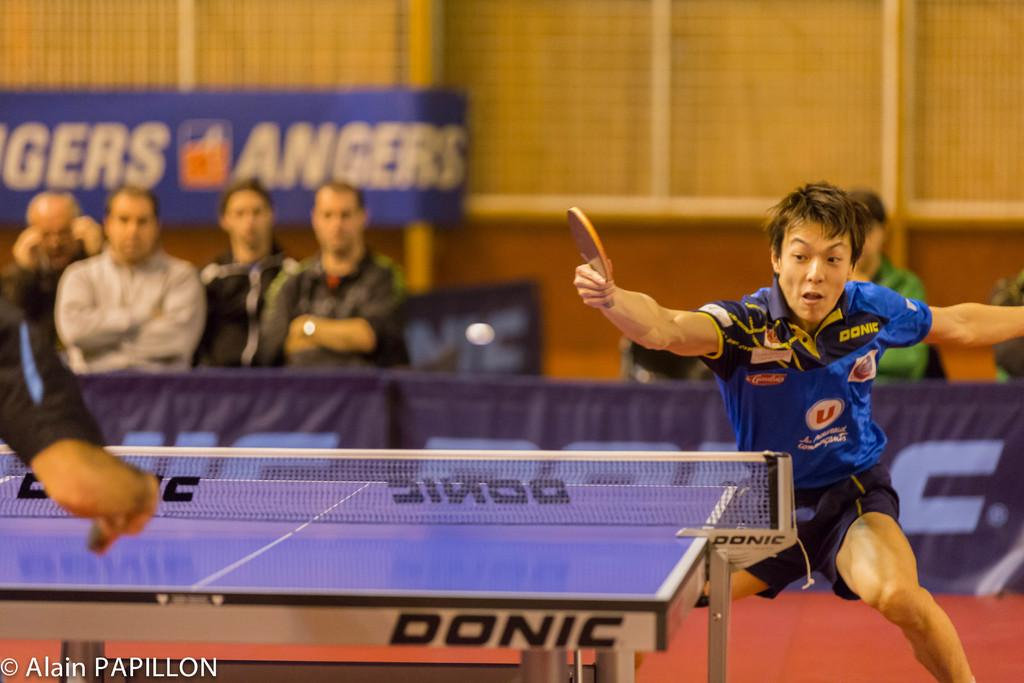What is the main object in the image? There is a table tennis board in the image. What is a key feature of the table tennis board? There is a net on the table tennis board. What is the man in the image holding? The man is holding a bat in his hands. Who else is present in the image besides the man with the bat? There are four people on the left side of the image watching a game. What type of plant is growing on the table tennis board? There is no plant growing on the table tennis board in the image. What angle is the earth tilted at in the image? The image does not depict the earth or any celestial bodies; it is focused on a table tennis game. 